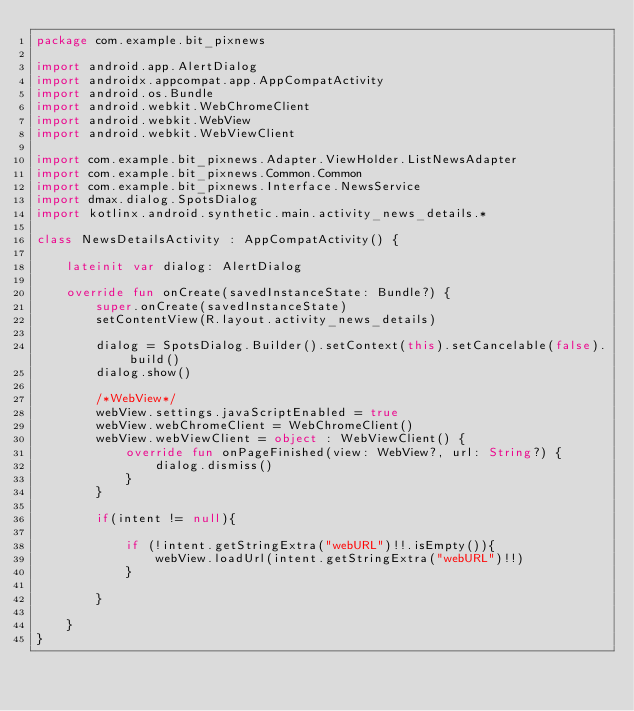Convert code to text. <code><loc_0><loc_0><loc_500><loc_500><_Kotlin_>package com.example.bit_pixnews

import android.app.AlertDialog
import androidx.appcompat.app.AppCompatActivity
import android.os.Bundle
import android.webkit.WebChromeClient
import android.webkit.WebView
import android.webkit.WebViewClient

import com.example.bit_pixnews.Adapter.ViewHolder.ListNewsAdapter
import com.example.bit_pixnews.Common.Common
import com.example.bit_pixnews.Interface.NewsService
import dmax.dialog.SpotsDialog
import kotlinx.android.synthetic.main.activity_news_details.*

class NewsDetailsActivity : AppCompatActivity() {

    lateinit var dialog: AlertDialog

    override fun onCreate(savedInstanceState: Bundle?) {
        super.onCreate(savedInstanceState)
        setContentView(R.layout.activity_news_details)

        dialog = SpotsDialog.Builder().setContext(this).setCancelable(false).build()
        dialog.show()

        /*WebView*/
        webView.settings.javaScriptEnabled = true
        webView.webChromeClient = WebChromeClient()
        webView.webViewClient = object : WebViewClient() {
            override fun onPageFinished(view: WebView?, url: String?) {
                dialog.dismiss()
            }
        }

        if(intent != null){

            if (!intent.getStringExtra("webURL")!!.isEmpty()){
                webView.loadUrl(intent.getStringExtra("webURL")!!)
            }

        }

    }
}</code> 